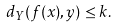Convert formula to latex. <formula><loc_0><loc_0><loc_500><loc_500>d _ { Y } ( f ( x ) , y ) \leq k .</formula> 